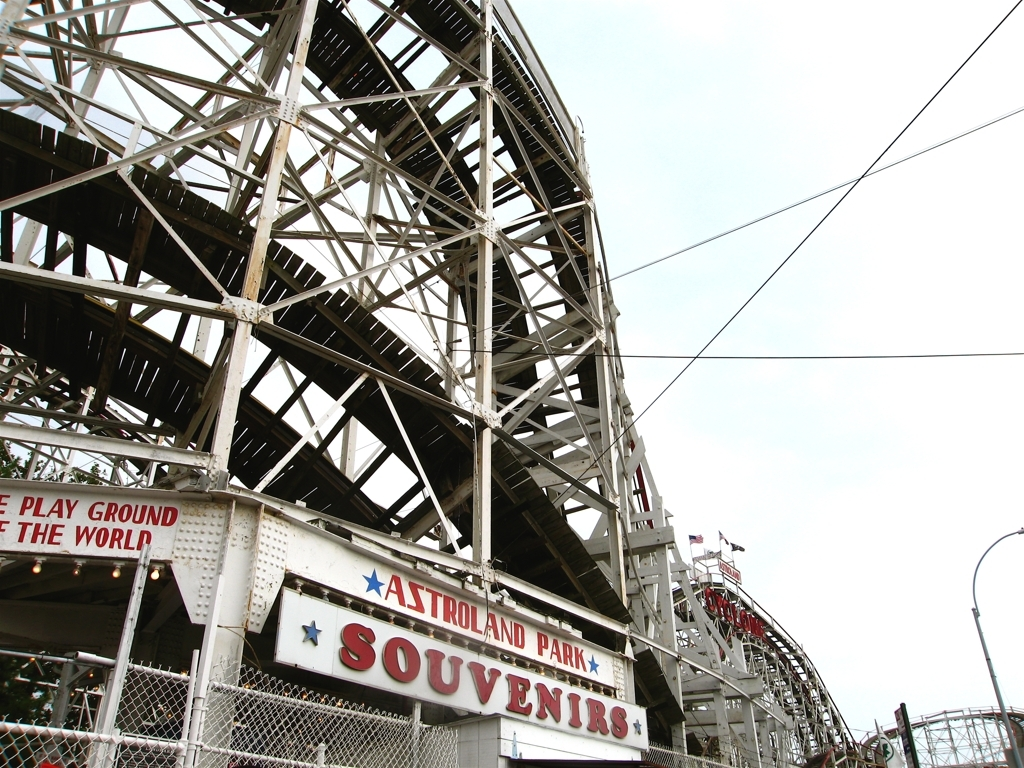What kind of emotions does this roller coaster evoke? The roller coaster's grand and tangled structure may evoke a sense of excitement and anticipation for thrill-seekers, while also possibly stirring a hint of nervousness due to its imposing frame and the potential for a thrilling ride. 